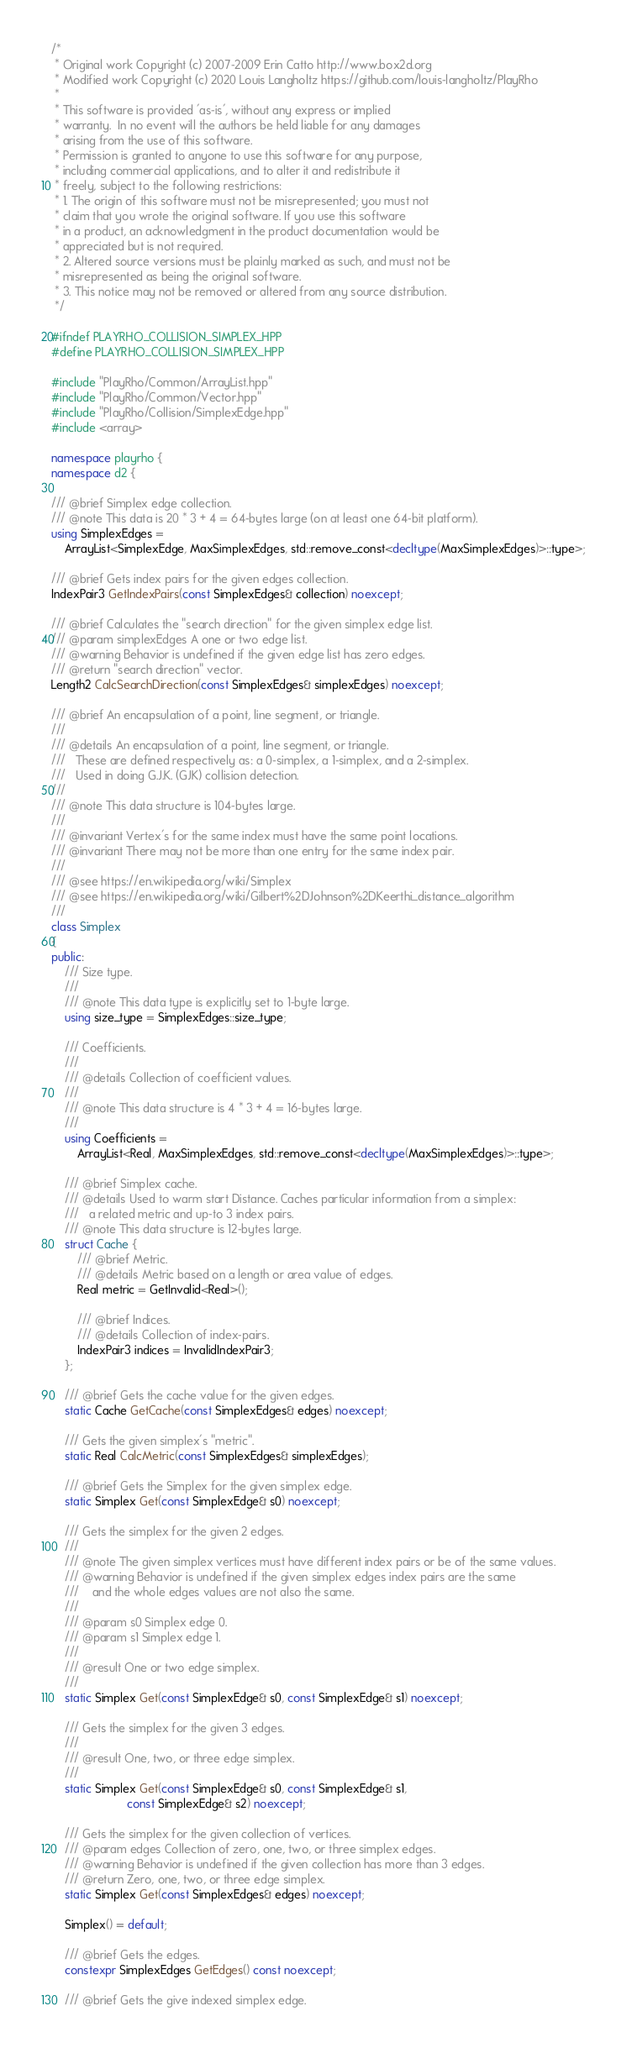Convert code to text. <code><loc_0><loc_0><loc_500><loc_500><_C++_>/*
 * Original work Copyright (c) 2007-2009 Erin Catto http://www.box2d.org
 * Modified work Copyright (c) 2020 Louis Langholtz https://github.com/louis-langholtz/PlayRho
 *
 * This software is provided 'as-is', without any express or implied
 * warranty.  In no event will the authors be held liable for any damages
 * arising from the use of this software.
 * Permission is granted to anyone to use this software for any purpose,
 * including commercial applications, and to alter it and redistribute it
 * freely, subject to the following restrictions:
 * 1. The origin of this software must not be misrepresented; you must not
 * claim that you wrote the original software. If you use this software
 * in a product, an acknowledgment in the product documentation would be
 * appreciated but is not required.
 * 2. Altered source versions must be plainly marked as such, and must not be
 * misrepresented as being the original software.
 * 3. This notice may not be removed or altered from any source distribution.
 */

#ifndef PLAYRHO_COLLISION_SIMPLEX_HPP
#define PLAYRHO_COLLISION_SIMPLEX_HPP

#include "PlayRho/Common/ArrayList.hpp"
#include "PlayRho/Common/Vector.hpp"
#include "PlayRho/Collision/SimplexEdge.hpp"
#include <array>

namespace playrho {
namespace d2 {

/// @brief Simplex edge collection.
/// @note This data is 20 * 3 + 4 = 64-bytes large (on at least one 64-bit platform).
using SimplexEdges =
    ArrayList<SimplexEdge, MaxSimplexEdges, std::remove_const<decltype(MaxSimplexEdges)>::type>;

/// @brief Gets index pairs for the given edges collection.
IndexPair3 GetIndexPairs(const SimplexEdges& collection) noexcept;

/// @brief Calculates the "search direction" for the given simplex edge list.
/// @param simplexEdges A one or two edge list.
/// @warning Behavior is undefined if the given edge list has zero edges.
/// @return "search direction" vector.
Length2 CalcSearchDirection(const SimplexEdges& simplexEdges) noexcept;

/// @brief An encapsulation of a point, line segment, or triangle.
///
/// @details An encapsulation of a point, line segment, or triangle.
///   These are defined respectively as: a 0-simplex, a 1-simplex, and a 2-simplex.
///   Used in doing G.J.K. (GJK) collision detection.
///
/// @note This data structure is 104-bytes large.
///
/// @invariant Vertex's for the same index must have the same point locations.
/// @invariant There may not be more than one entry for the same index pair.
///
/// @see https://en.wikipedia.org/wiki/Simplex
/// @see https://en.wikipedia.org/wiki/Gilbert%2DJohnson%2DKeerthi_distance_algorithm
///
class Simplex
{
public:
    /// Size type.
    ///
    /// @note This data type is explicitly set to 1-byte large.
    using size_type = SimplexEdges::size_type;

    /// Coefficients.
    ///
    /// @details Collection of coefficient values.
    ///
    /// @note This data structure is 4 * 3 + 4 = 16-bytes large.
    ///
    using Coefficients =
        ArrayList<Real, MaxSimplexEdges, std::remove_const<decltype(MaxSimplexEdges)>::type>;

    /// @brief Simplex cache.
    /// @details Used to warm start Distance. Caches particular information from a simplex:
    ///   a related metric and up-to 3 index pairs.
    /// @note This data structure is 12-bytes large.
    struct Cache {
        /// @brief Metric.
        /// @details Metric based on a length or area value of edges.
        Real metric = GetInvalid<Real>();

        /// @brief Indices.
        /// @details Collection of index-pairs.
        IndexPair3 indices = InvalidIndexPair3;
    };

    /// @brief Gets the cache value for the given edges.
    static Cache GetCache(const SimplexEdges& edges) noexcept;

    /// Gets the given simplex's "metric".
    static Real CalcMetric(const SimplexEdges& simplexEdges);

    /// @brief Gets the Simplex for the given simplex edge.
    static Simplex Get(const SimplexEdge& s0) noexcept;

    /// Gets the simplex for the given 2 edges.
    ///
    /// @note The given simplex vertices must have different index pairs or be of the same values.
    /// @warning Behavior is undefined if the given simplex edges index pairs are the same
    ///    and the whole edges values are not also the same.
    ///
    /// @param s0 Simplex edge 0.
    /// @param s1 Simplex edge 1.
    ///
    /// @result One or two edge simplex.
    ///
    static Simplex Get(const SimplexEdge& s0, const SimplexEdge& s1) noexcept;

    /// Gets the simplex for the given 3 edges.
    ///
    /// @result One, two, or three edge simplex.
    ///
    static Simplex Get(const SimplexEdge& s0, const SimplexEdge& s1,
                       const SimplexEdge& s2) noexcept;

    /// Gets the simplex for the given collection of vertices.
    /// @param edges Collection of zero, one, two, or three simplex edges.
    /// @warning Behavior is undefined if the given collection has more than 3 edges.
    /// @return Zero, one, two, or three edge simplex.
    static Simplex Get(const SimplexEdges& edges) noexcept;

    Simplex() = default;

    /// @brief Gets the edges.
    constexpr SimplexEdges GetEdges() const noexcept;

    /// @brief Gets the give indexed simplex edge.</code> 